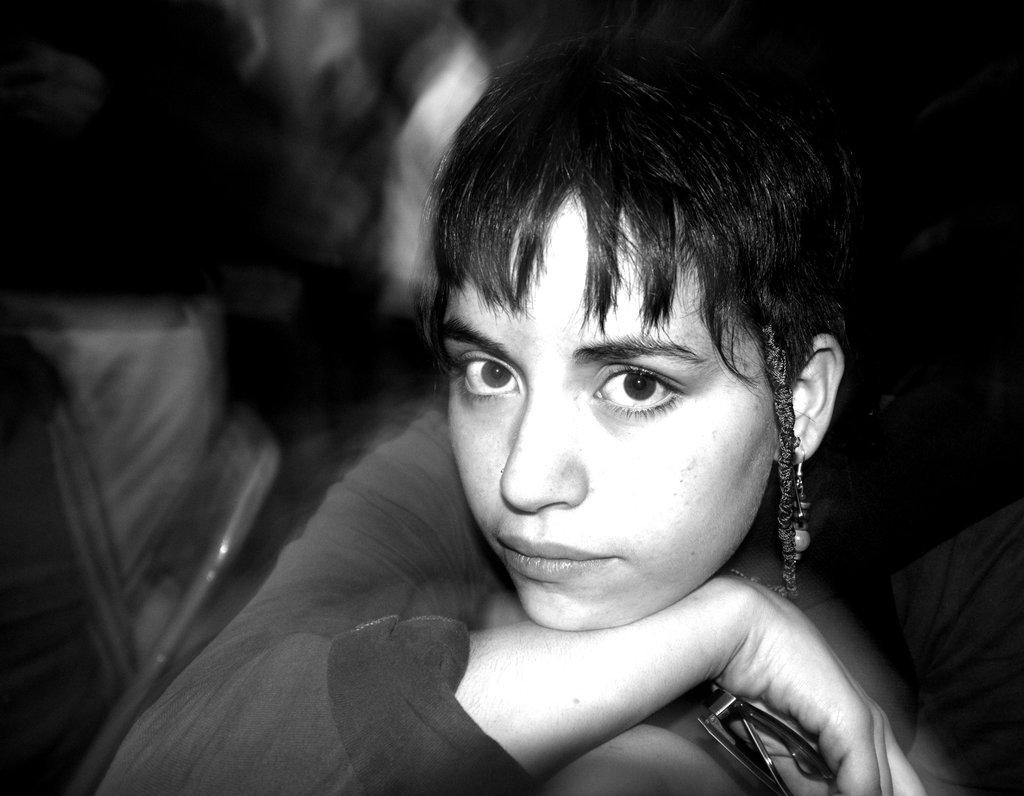What is the color scheme of the image? The image is black and white. Can you describe the main subject in the foreground of the image? There is a woman in the foreground of the image. What type of produce is being washed in the sink in the image? There is no sink or produce present in the image; it is a black and white image featuring a woman in the foreground. 